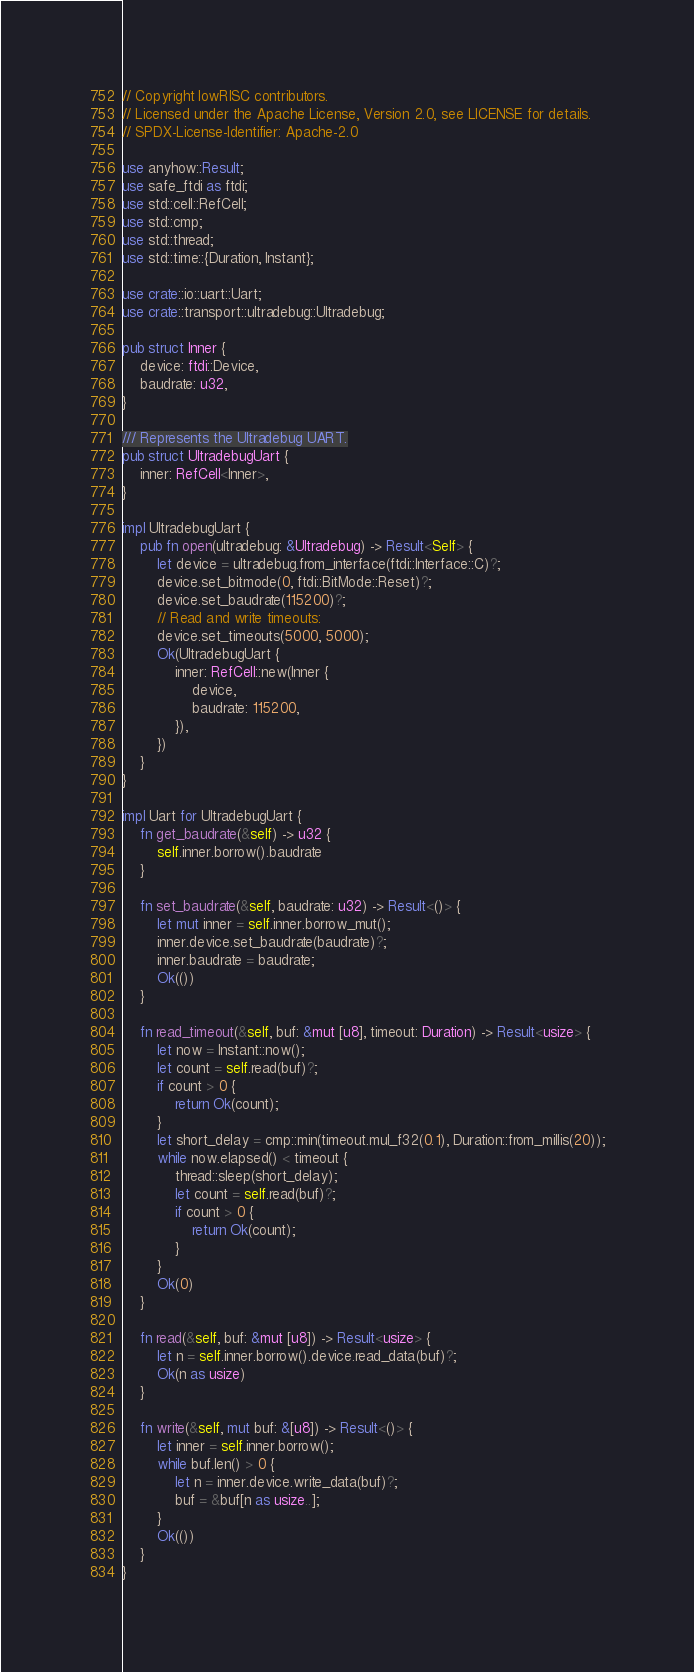<code> <loc_0><loc_0><loc_500><loc_500><_Rust_>// Copyright lowRISC contributors.
// Licensed under the Apache License, Version 2.0, see LICENSE for details.
// SPDX-License-Identifier: Apache-2.0

use anyhow::Result;
use safe_ftdi as ftdi;
use std::cell::RefCell;
use std::cmp;
use std::thread;
use std::time::{Duration, Instant};

use crate::io::uart::Uart;
use crate::transport::ultradebug::Ultradebug;

pub struct Inner {
    device: ftdi::Device,
    baudrate: u32,
}

/// Represents the Ultradebug UART.
pub struct UltradebugUart {
    inner: RefCell<Inner>,
}

impl UltradebugUart {
    pub fn open(ultradebug: &Ultradebug) -> Result<Self> {
        let device = ultradebug.from_interface(ftdi::Interface::C)?;
        device.set_bitmode(0, ftdi::BitMode::Reset)?;
        device.set_baudrate(115200)?;
        // Read and write timeouts:
        device.set_timeouts(5000, 5000);
        Ok(UltradebugUart {
            inner: RefCell::new(Inner {
                device,
                baudrate: 115200,
            }),
        })
    }
}

impl Uart for UltradebugUart {
    fn get_baudrate(&self) -> u32 {
        self.inner.borrow().baudrate
    }

    fn set_baudrate(&self, baudrate: u32) -> Result<()> {
        let mut inner = self.inner.borrow_mut();
        inner.device.set_baudrate(baudrate)?;
        inner.baudrate = baudrate;
        Ok(())
    }

    fn read_timeout(&self, buf: &mut [u8], timeout: Duration) -> Result<usize> {
        let now = Instant::now();
        let count = self.read(buf)?;
        if count > 0 {
            return Ok(count);
        }
        let short_delay = cmp::min(timeout.mul_f32(0.1), Duration::from_millis(20));
        while now.elapsed() < timeout {
            thread::sleep(short_delay);
            let count = self.read(buf)?;
            if count > 0 {
                return Ok(count);
            }
        }
        Ok(0)
    }

    fn read(&self, buf: &mut [u8]) -> Result<usize> {
        let n = self.inner.borrow().device.read_data(buf)?;
        Ok(n as usize)
    }

    fn write(&self, mut buf: &[u8]) -> Result<()> {
        let inner = self.inner.borrow();
        while buf.len() > 0 {
            let n = inner.device.write_data(buf)?;
            buf = &buf[n as usize..];
        }
        Ok(())
    }
}
</code> 